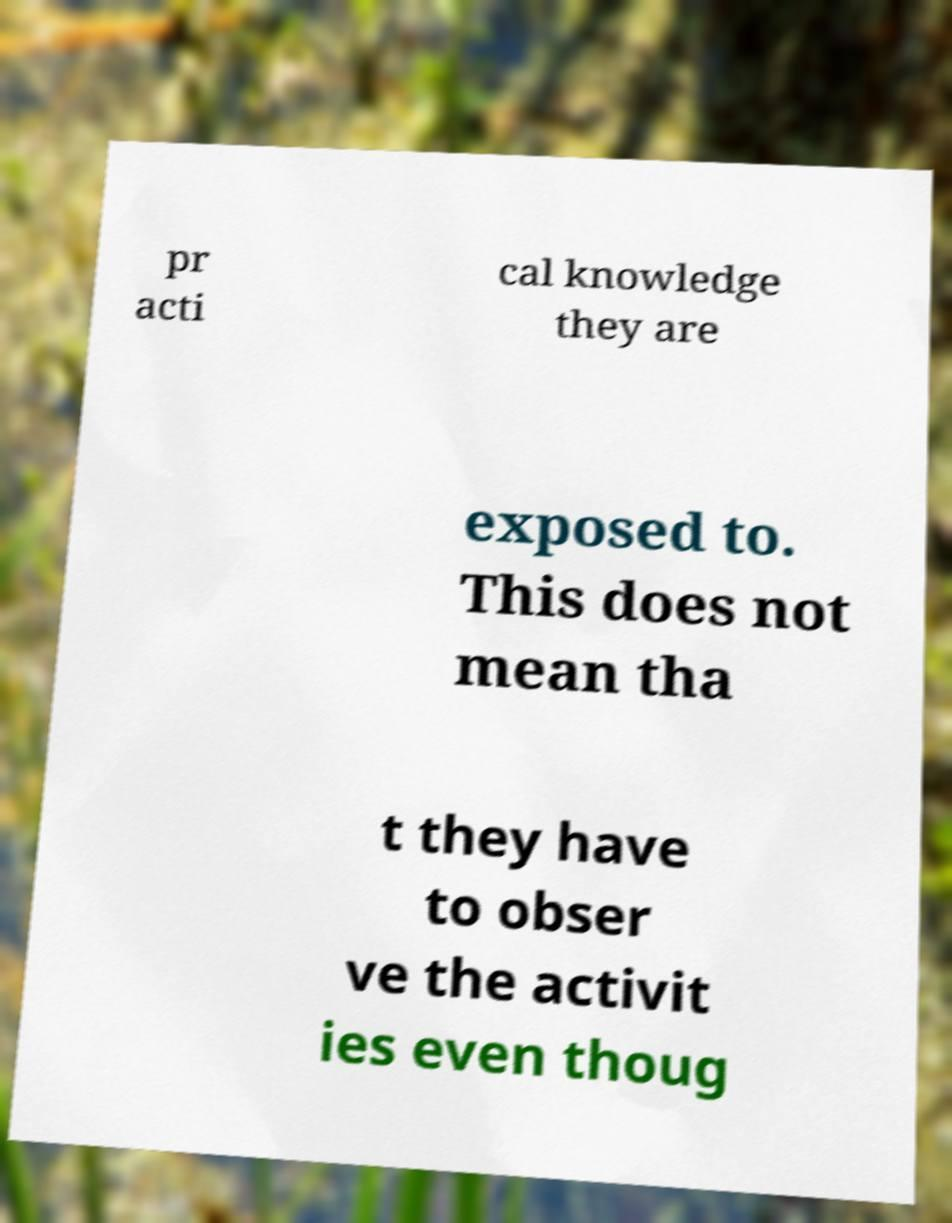There's text embedded in this image that I need extracted. Can you transcribe it verbatim? pr acti cal knowledge they are exposed to. This does not mean tha t they have to obser ve the activit ies even thoug 